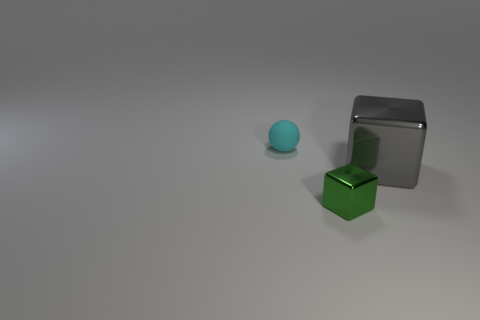How many objects are tiny objects or blue matte spheres? In the image, there is one tiny object (a small blue sphere) and no blue matte spheres. Thus, the total count of tiny objects or blue matte spheres is one. 